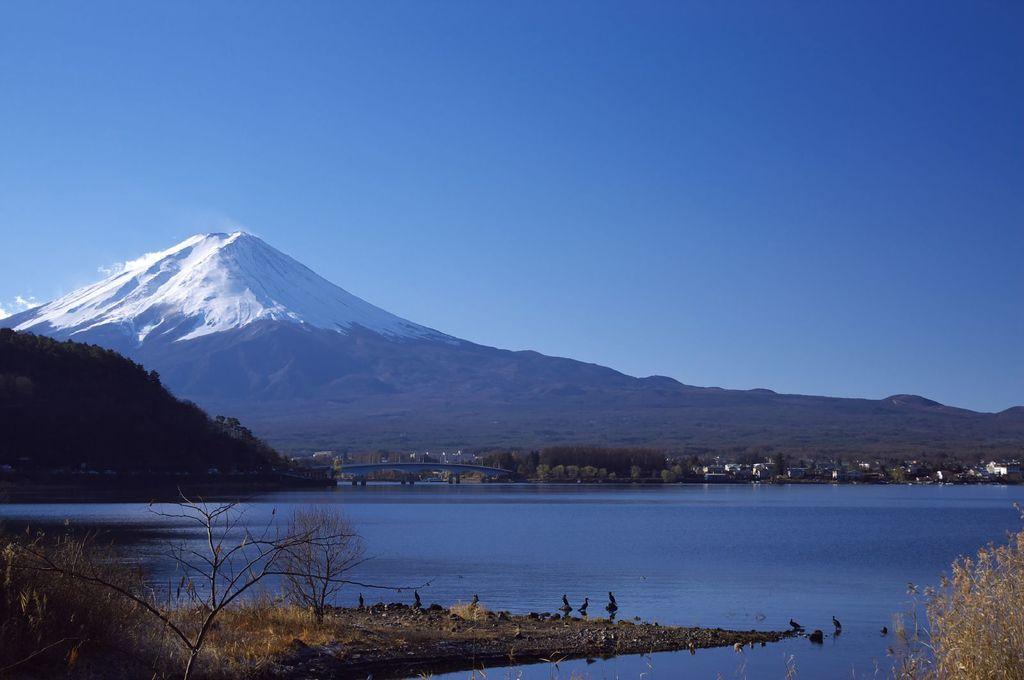Can you describe this image briefly? In this image, we can see trees, hills, buildings and there is a bridge. At the top, there is sky and at the bottom, there is water and we can see some birds. 